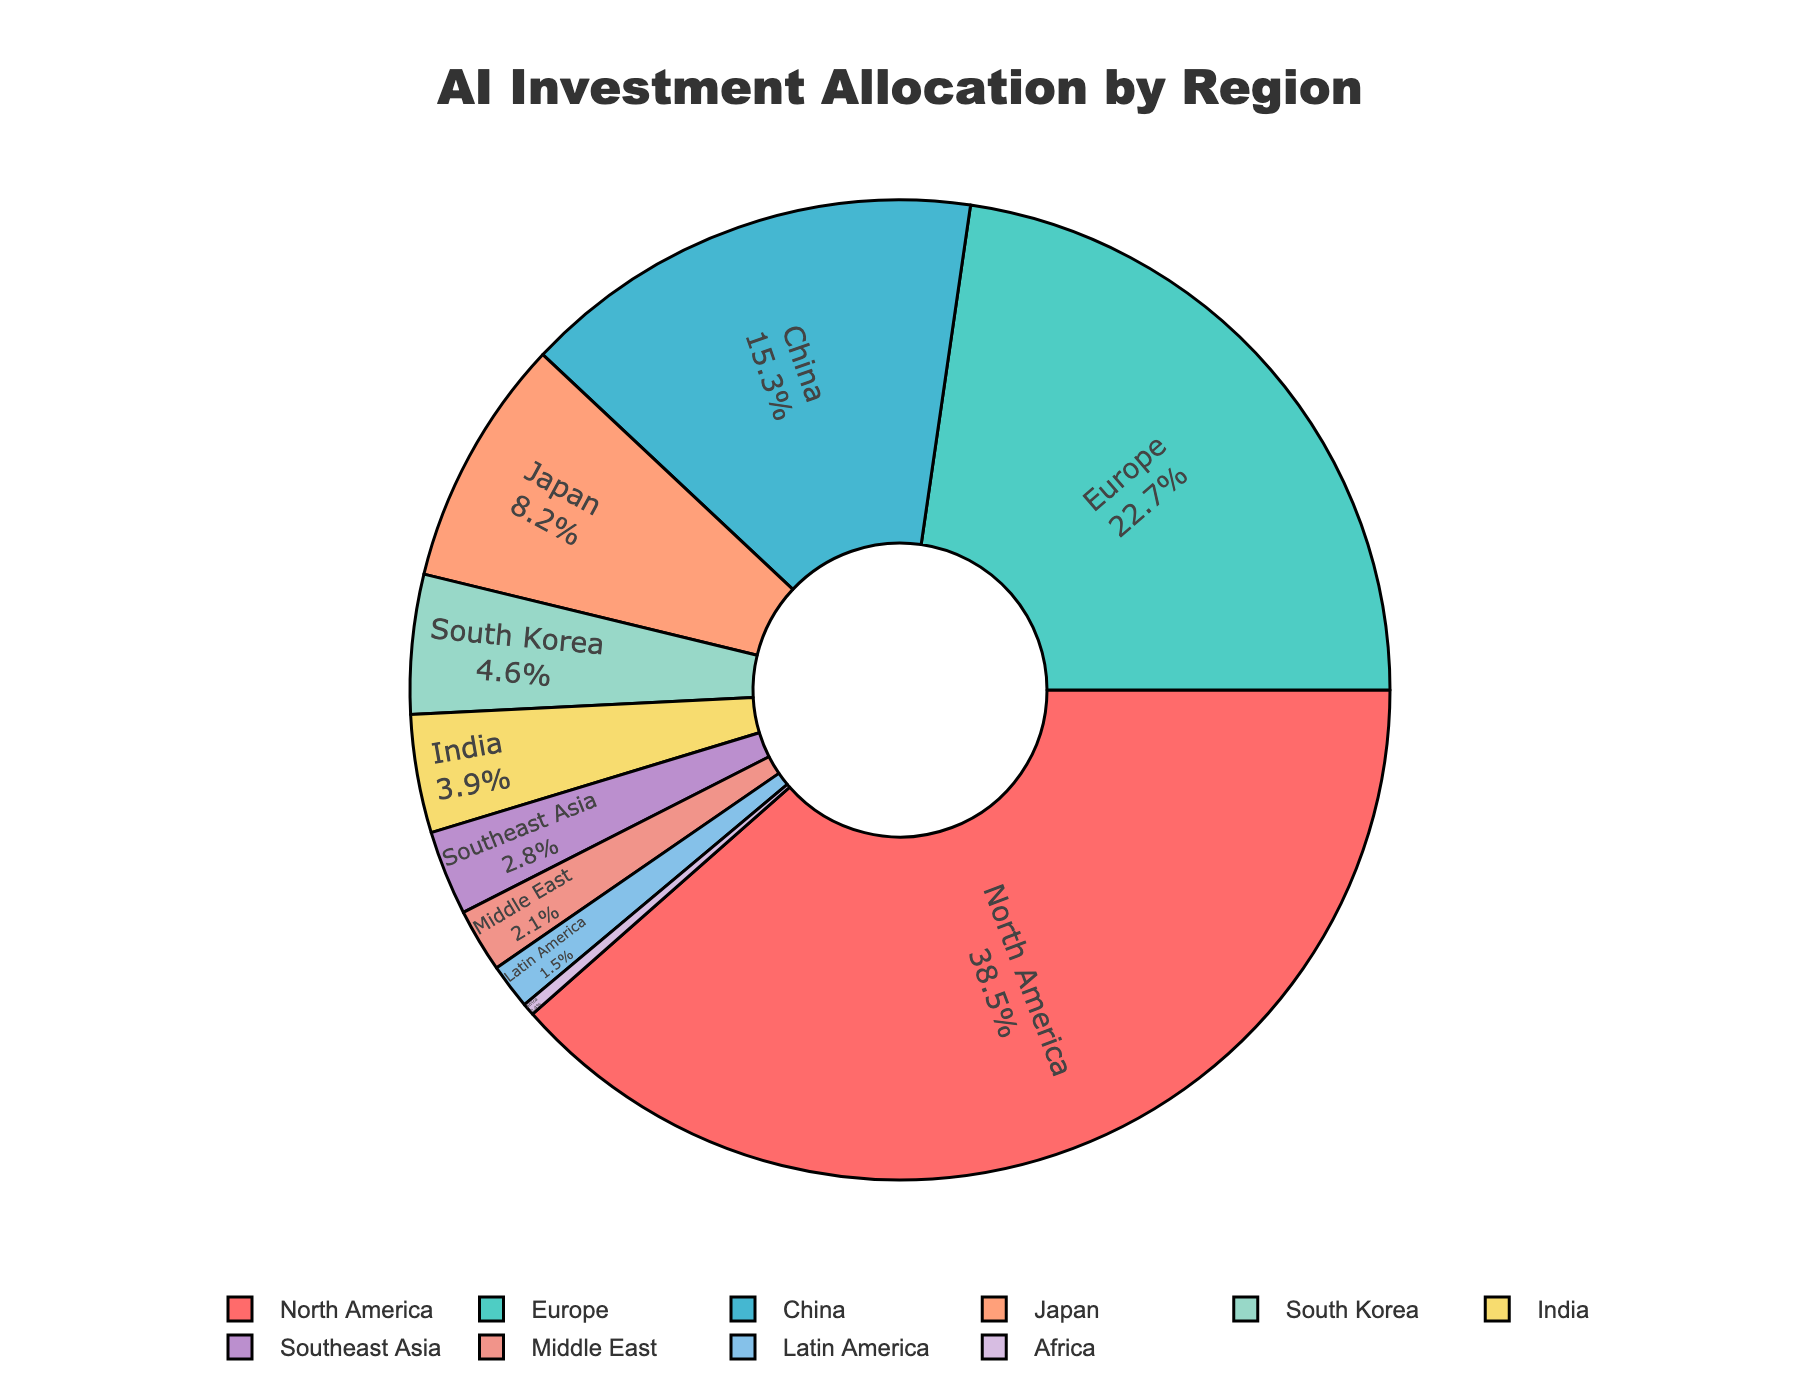Which region has the highest AI investment percentage? North America has the highest AI investment allocation. This can be determined by noting that North America's portion of the pie chart is the largest, labeled with 38.5%.
Answer: North America What is the combined AI investment percentage for China, Japan, and South Korea? To find the combined percentage, sum the individual percentages for China (15.3%), Japan (8.2%), and South Korea (4.6%). The calculation is 15.3 + 8.2 + 4.6 = 28.1%.
Answer: 28.1% How does Europe's AI investment percentage compare to that of North America? Europe has 22.7% of AI investments whereas North America has 38.5%. Comparing these, North America's percentage is significantly higher. To compare numerically, 38.5% - 22.7% = 15.8%.
Answer: North America has 15.8% more Which region has the smallest AI investment percentage? By observing the pie chart, Africa has the smallest portion, labeled with 0.4%.
Answer: Africa What is the difference in AI investment percentage between India and Southeast Asia? India's AI investment percentage is 3.9% and Southeast Asia's is 2.8%. To find the difference, subtract 2.8% from 3.9%, which is 1.1%.
Answer: 1.1% If the total AI investment were $1 billion, how much investment would be allocated to Europe? With Europe having 22.7% of the AI investment, calculate 22.7% of $1 billion, which is (0.227 * 1,000,000,000) = $227 million.
Answer: $227 million What percentage of AI investment is allocated outside North America and Europe? The total percentage excluding North America (38.5%) and Europe (22.7%) is 100% - (38.5% + 22.7%) = 38.8%.
Answer: 38.8% Is Latin America's AI investment percentage more or less than double that of Africa? Latin America's percentage is 1.5% and Africa's is 0.4%. To compare, double Africa's percentage is 2 * 0.4% = 0.8%. Since 1.5% > 0.8%, Latin America's investment is more than double that of Africa.
Answer: More Rank the regions in descending order of AI investment percentage. The regions ranked from highest to lowest investment percentage are:
1. North America (38.5%)
2. Europe (22.7%)
3. China (15.3%)
4. Japan (8.2%)
5. South Korea (4.6%)
6. India (3.9%)
7. Southeast Asia (2.8%)
8. Middle East (2.1%)
9. Latin America (1.5%)
10. Africa (0.4%).
Answer: Ordered list provided above What is the average AI investment percentage of the regions with less than 5% allocation? First identify the regions with less than 5% allocation: South Korea (4.6%), India (3.9%), Southeast Asia (2.8%), Middle East (2.1%), Latin America (1.5%), Africa (0.4%). Add these percentages (4.6 + 3.9 + 2.8 + 2.1 + 1.5 + 0.4 = 15.3) and then divide by the number of regions (6). The average is 15.3 / 6 ≈ 2.55%.
Answer: 2.55% 